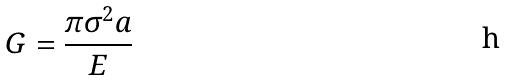<formula> <loc_0><loc_0><loc_500><loc_500>G = \frac { \pi \sigma ^ { 2 } a } { E }</formula> 